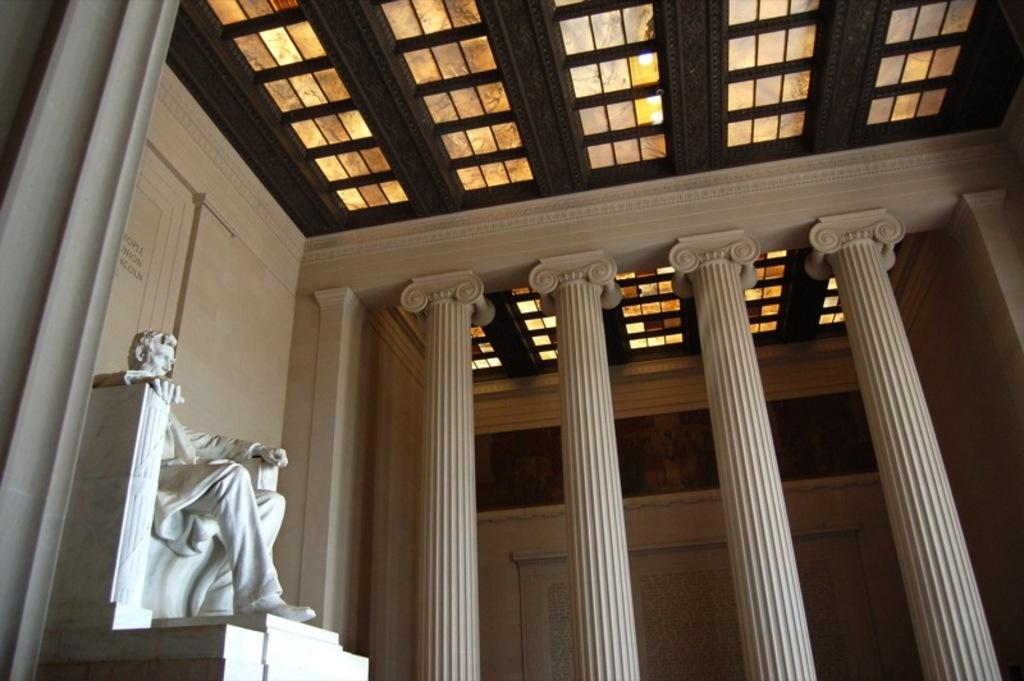Where was the image taken? The image was taken inside a building. What architectural features can be seen in the image? There are pillars in the image. What type of artwork is present in the image? There is a sculpture of a man in the image. What part of the building is visible at the top of the image? The ceiling is visible at the top of the image. What type of straw is used to create the bushes in the image? There are no bushes or straw present in the image; it features pillars, a sculpture, and a ceiling. What is the taste of the sculpture in the image? The sculpture is not edible, so it does not have a taste. 